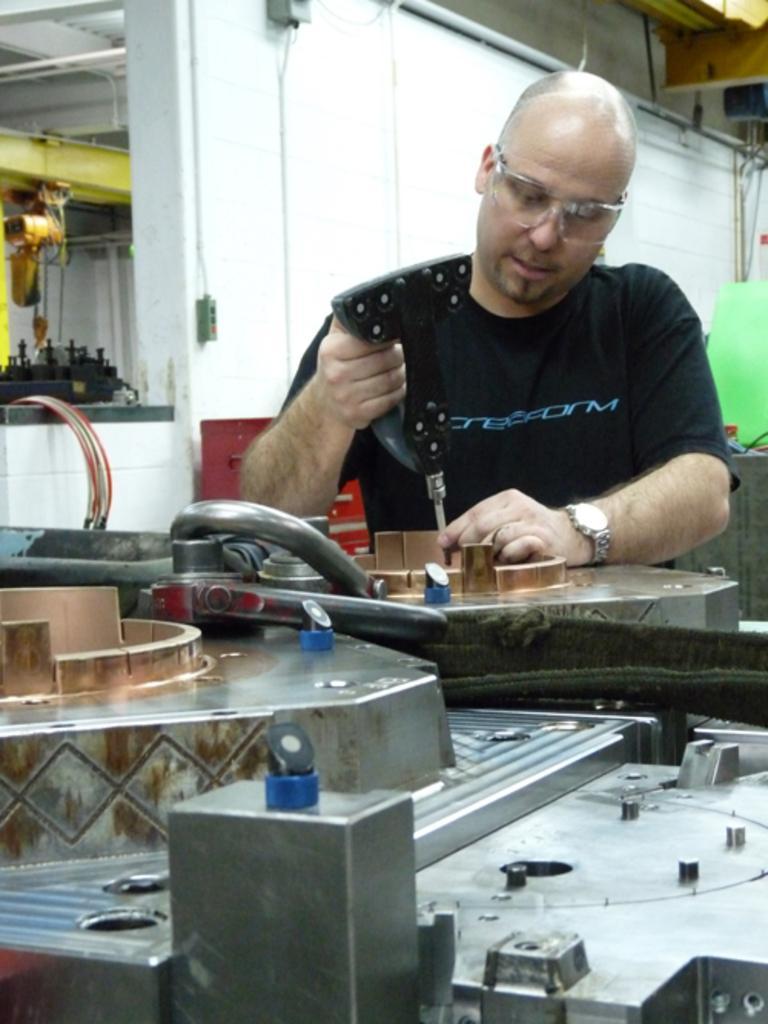Can you describe this image briefly? In this image there are some machines, a person holding a hand drilling machine and repairing something , wall, cables. 